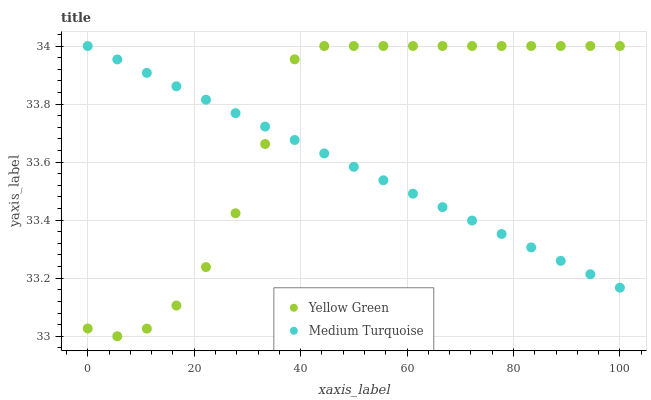Does Medium Turquoise have the minimum area under the curve?
Answer yes or no. Yes. Does Yellow Green have the maximum area under the curve?
Answer yes or no. Yes. Does Medium Turquoise have the maximum area under the curve?
Answer yes or no. No. Is Medium Turquoise the smoothest?
Answer yes or no. Yes. Is Yellow Green the roughest?
Answer yes or no. Yes. Is Medium Turquoise the roughest?
Answer yes or no. No. Does Yellow Green have the lowest value?
Answer yes or no. Yes. Does Medium Turquoise have the lowest value?
Answer yes or no. No. Does Medium Turquoise have the highest value?
Answer yes or no. Yes. Does Yellow Green intersect Medium Turquoise?
Answer yes or no. Yes. Is Yellow Green less than Medium Turquoise?
Answer yes or no. No. Is Yellow Green greater than Medium Turquoise?
Answer yes or no. No. 